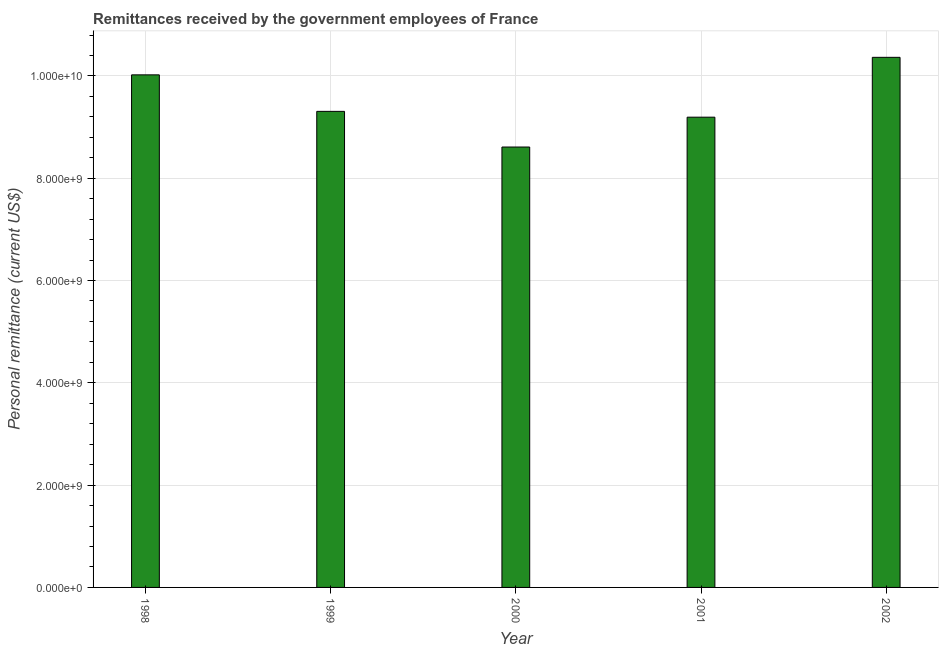Does the graph contain any zero values?
Your response must be concise. No. Does the graph contain grids?
Make the answer very short. Yes. What is the title of the graph?
Your response must be concise. Remittances received by the government employees of France. What is the label or title of the Y-axis?
Ensure brevity in your answer.  Personal remittance (current US$). What is the personal remittances in 1999?
Keep it short and to the point. 9.31e+09. Across all years, what is the maximum personal remittances?
Provide a short and direct response. 1.04e+1. Across all years, what is the minimum personal remittances?
Keep it short and to the point. 8.61e+09. In which year was the personal remittances maximum?
Make the answer very short. 2002. In which year was the personal remittances minimum?
Your answer should be very brief. 2000. What is the sum of the personal remittances?
Make the answer very short. 4.75e+1. What is the difference between the personal remittances in 1998 and 2002?
Keep it short and to the point. -3.43e+08. What is the average personal remittances per year?
Keep it short and to the point. 9.50e+09. What is the median personal remittances?
Give a very brief answer. 9.31e+09. In how many years, is the personal remittances greater than 5200000000 US$?
Offer a very short reply. 5. What is the ratio of the personal remittances in 2000 to that in 2001?
Offer a terse response. 0.94. Is the personal remittances in 2000 less than that in 2001?
Make the answer very short. Yes. What is the difference between the highest and the second highest personal remittances?
Offer a terse response. 3.43e+08. Is the sum of the personal remittances in 1998 and 1999 greater than the maximum personal remittances across all years?
Make the answer very short. Yes. What is the difference between the highest and the lowest personal remittances?
Your answer should be compact. 1.75e+09. What is the difference between two consecutive major ticks on the Y-axis?
Make the answer very short. 2.00e+09. What is the Personal remittance (current US$) in 1998?
Your response must be concise. 1.00e+1. What is the Personal remittance (current US$) of 1999?
Provide a succinct answer. 9.31e+09. What is the Personal remittance (current US$) of 2000?
Provide a short and direct response. 8.61e+09. What is the Personal remittance (current US$) of 2001?
Provide a succinct answer. 9.19e+09. What is the Personal remittance (current US$) in 2002?
Keep it short and to the point. 1.04e+1. What is the difference between the Personal remittance (current US$) in 1998 and 1999?
Provide a succinct answer. 7.14e+08. What is the difference between the Personal remittance (current US$) in 1998 and 2000?
Your answer should be compact. 1.41e+09. What is the difference between the Personal remittance (current US$) in 1998 and 2001?
Make the answer very short. 8.28e+08. What is the difference between the Personal remittance (current US$) in 1998 and 2002?
Your response must be concise. -3.43e+08. What is the difference between the Personal remittance (current US$) in 1999 and 2000?
Provide a succinct answer. 6.97e+08. What is the difference between the Personal remittance (current US$) in 1999 and 2001?
Your answer should be very brief. 1.14e+08. What is the difference between the Personal remittance (current US$) in 1999 and 2002?
Give a very brief answer. -1.06e+09. What is the difference between the Personal remittance (current US$) in 2000 and 2001?
Give a very brief answer. -5.83e+08. What is the difference between the Personal remittance (current US$) in 2000 and 2002?
Provide a succinct answer. -1.75e+09. What is the difference between the Personal remittance (current US$) in 2001 and 2002?
Provide a short and direct response. -1.17e+09. What is the ratio of the Personal remittance (current US$) in 1998 to that in 1999?
Provide a succinct answer. 1.08. What is the ratio of the Personal remittance (current US$) in 1998 to that in 2000?
Your response must be concise. 1.16. What is the ratio of the Personal remittance (current US$) in 1998 to that in 2001?
Your answer should be compact. 1.09. What is the ratio of the Personal remittance (current US$) in 1999 to that in 2000?
Offer a terse response. 1.08. What is the ratio of the Personal remittance (current US$) in 1999 to that in 2001?
Provide a succinct answer. 1.01. What is the ratio of the Personal remittance (current US$) in 1999 to that in 2002?
Offer a terse response. 0.9. What is the ratio of the Personal remittance (current US$) in 2000 to that in 2001?
Make the answer very short. 0.94. What is the ratio of the Personal remittance (current US$) in 2000 to that in 2002?
Keep it short and to the point. 0.83. What is the ratio of the Personal remittance (current US$) in 2001 to that in 2002?
Offer a terse response. 0.89. 